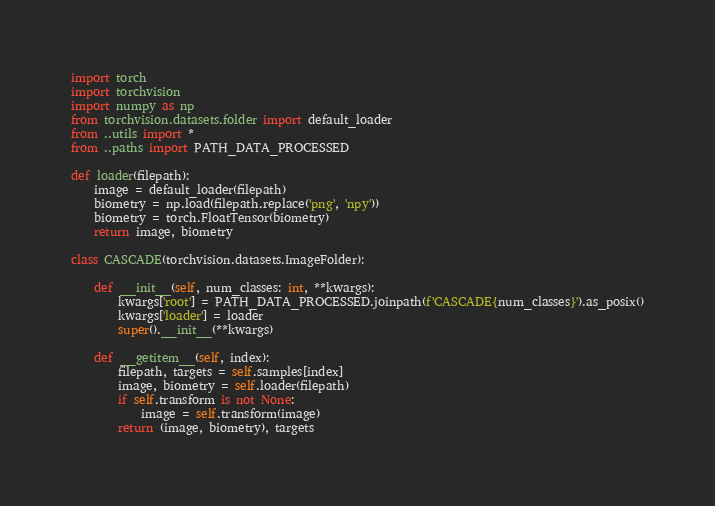<code> <loc_0><loc_0><loc_500><loc_500><_Python_>import torch
import torchvision
import numpy as np
from torchvision.datasets.folder import default_loader
from ..utils import *
from ..paths import PATH_DATA_PROCESSED

def loader(filepath):
    image = default_loader(filepath)
    biometry = np.load(filepath.replace('png', 'npy'))
    biometry = torch.FloatTensor(biometry)
    return image, biometry

class CASCADE(torchvision.datasets.ImageFolder):

    def __init__(self, num_classes: int, **kwargs):
        kwargs['root'] = PATH_DATA_PROCESSED.joinpath(f'CASCADE{num_classes}').as_posix()
        kwargs['loader'] = loader
        super().__init__(**kwargs)

    def __getitem__(self, index):
        filepath, targets = self.samples[index]
        image, biometry = self.loader(filepath)
        if self.transform is not None:
            image = self.transform(image)
        return (image, biometry), targets
</code> 